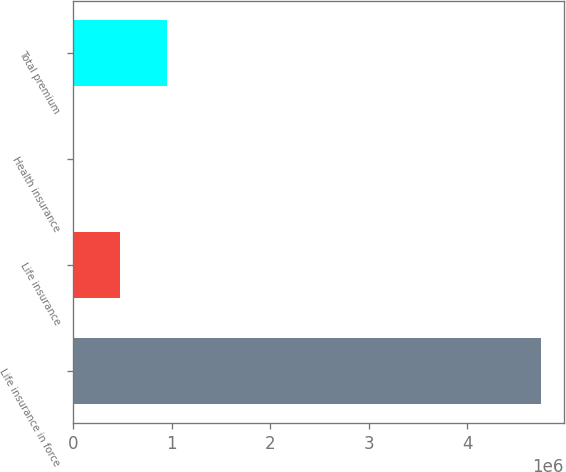Convert chart. <chart><loc_0><loc_0><loc_500><loc_500><bar_chart><fcel>Life insurance in force<fcel>Life insurance<fcel>Health insurance<fcel>Total premium<nl><fcel>4.74322e+06<fcel>474325<fcel>2.95<fcel>948647<nl></chart> 